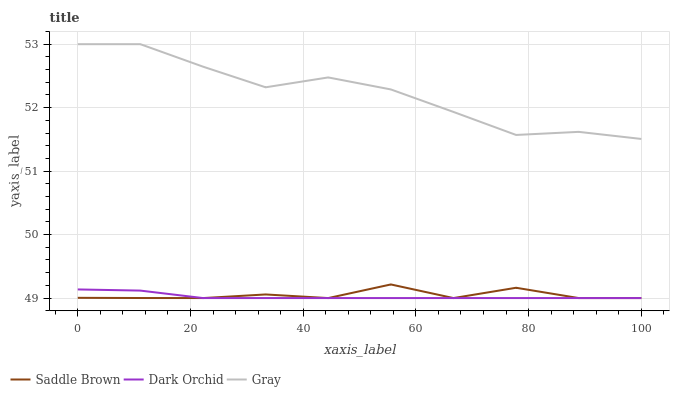Does Dark Orchid have the minimum area under the curve?
Answer yes or no. Yes. Does Gray have the maximum area under the curve?
Answer yes or no. Yes. Does Saddle Brown have the minimum area under the curve?
Answer yes or no. No. Does Saddle Brown have the maximum area under the curve?
Answer yes or no. No. Is Dark Orchid the smoothest?
Answer yes or no. Yes. Is Gray the roughest?
Answer yes or no. Yes. Is Saddle Brown the smoothest?
Answer yes or no. No. Is Saddle Brown the roughest?
Answer yes or no. No. Does Saddle Brown have the lowest value?
Answer yes or no. Yes. Does Gray have the highest value?
Answer yes or no. Yes. Does Saddle Brown have the highest value?
Answer yes or no. No. Is Saddle Brown less than Gray?
Answer yes or no. Yes. Is Gray greater than Saddle Brown?
Answer yes or no. Yes. Does Dark Orchid intersect Saddle Brown?
Answer yes or no. Yes. Is Dark Orchid less than Saddle Brown?
Answer yes or no. No. Is Dark Orchid greater than Saddle Brown?
Answer yes or no. No. Does Saddle Brown intersect Gray?
Answer yes or no. No. 